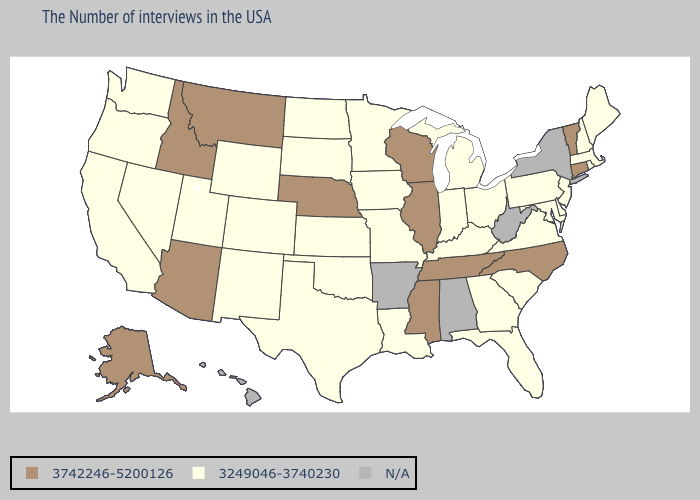What is the lowest value in the South?
Short answer required. 3249046-3740230. What is the value of New York?
Keep it brief. N/A. Among the states that border Wisconsin , does Illinois have the lowest value?
Keep it brief. No. Name the states that have a value in the range 3742246-5200126?
Be succinct. Vermont, Connecticut, North Carolina, Tennessee, Wisconsin, Illinois, Mississippi, Nebraska, Montana, Arizona, Idaho, Alaska. Is the legend a continuous bar?
Concise answer only. No. Name the states that have a value in the range 3249046-3740230?
Short answer required. Maine, Massachusetts, Rhode Island, New Hampshire, New Jersey, Delaware, Maryland, Pennsylvania, Virginia, South Carolina, Ohio, Florida, Georgia, Michigan, Kentucky, Indiana, Louisiana, Missouri, Minnesota, Iowa, Kansas, Oklahoma, Texas, South Dakota, North Dakota, Wyoming, Colorado, New Mexico, Utah, Nevada, California, Washington, Oregon. Is the legend a continuous bar?
Write a very short answer. No. Does the map have missing data?
Be succinct. Yes. Which states have the highest value in the USA?
Keep it brief. Vermont, Connecticut, North Carolina, Tennessee, Wisconsin, Illinois, Mississippi, Nebraska, Montana, Arizona, Idaho, Alaska. Name the states that have a value in the range 3742246-5200126?
Concise answer only. Vermont, Connecticut, North Carolina, Tennessee, Wisconsin, Illinois, Mississippi, Nebraska, Montana, Arizona, Idaho, Alaska. What is the value of New Mexico?
Quick response, please. 3249046-3740230. Which states have the lowest value in the West?
Short answer required. Wyoming, Colorado, New Mexico, Utah, Nevada, California, Washington, Oregon. What is the value of Colorado?
Answer briefly. 3249046-3740230. 